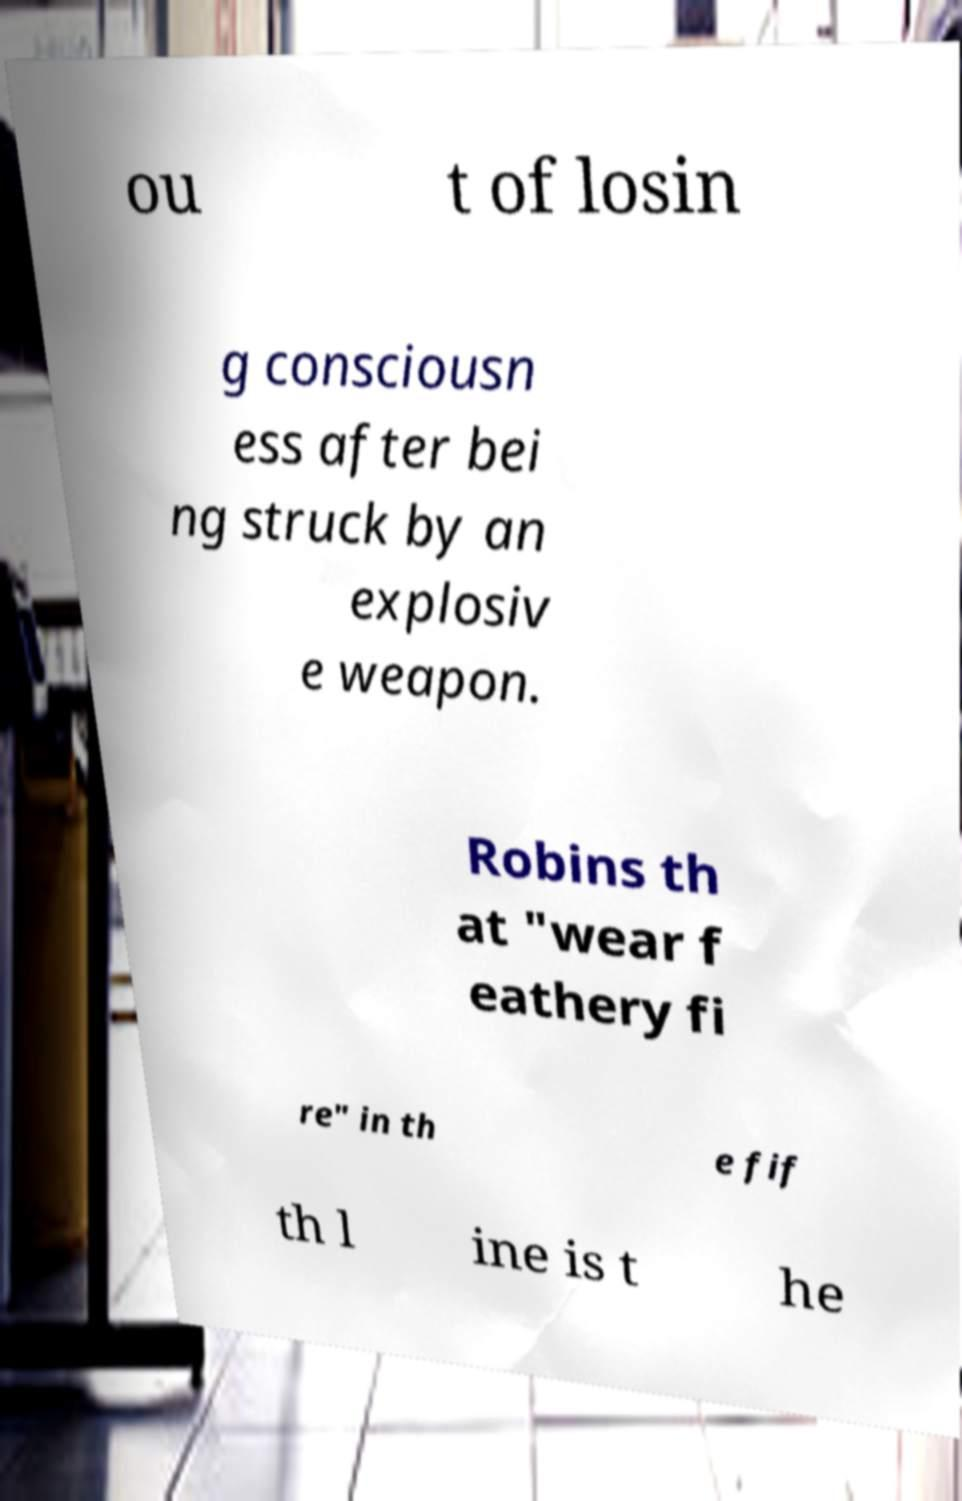Please identify and transcribe the text found in this image. ou t of losin g consciousn ess after bei ng struck by an explosiv e weapon. Robins th at "wear f eathery fi re" in th e fif th l ine is t he 